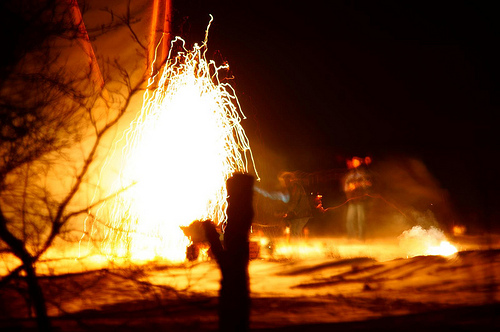<image>
Is the water on the fire? Yes. Looking at the image, I can see the water is positioned on top of the fire, with the fire providing support. Where is the man in relation to the tree? Is it in front of the tree? No. The man is not in front of the tree. The spatial positioning shows a different relationship between these objects. 